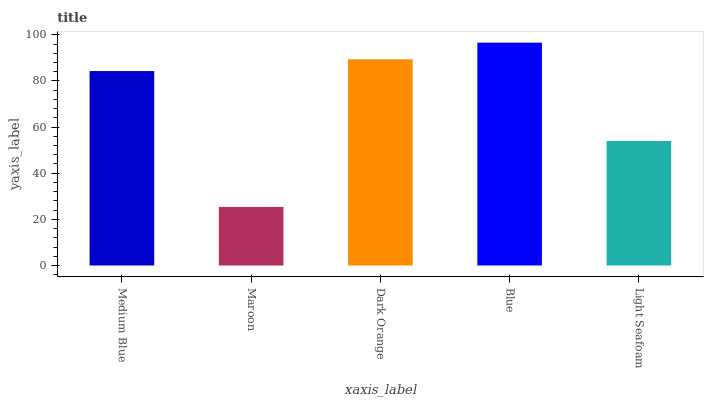Is Maroon the minimum?
Answer yes or no. Yes. Is Blue the maximum?
Answer yes or no. Yes. Is Dark Orange the minimum?
Answer yes or no. No. Is Dark Orange the maximum?
Answer yes or no. No. Is Dark Orange greater than Maroon?
Answer yes or no. Yes. Is Maroon less than Dark Orange?
Answer yes or no. Yes. Is Maroon greater than Dark Orange?
Answer yes or no. No. Is Dark Orange less than Maroon?
Answer yes or no. No. Is Medium Blue the high median?
Answer yes or no. Yes. Is Medium Blue the low median?
Answer yes or no. Yes. Is Maroon the high median?
Answer yes or no. No. Is Maroon the low median?
Answer yes or no. No. 